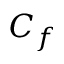<formula> <loc_0><loc_0><loc_500><loc_500>C _ { f }</formula> 